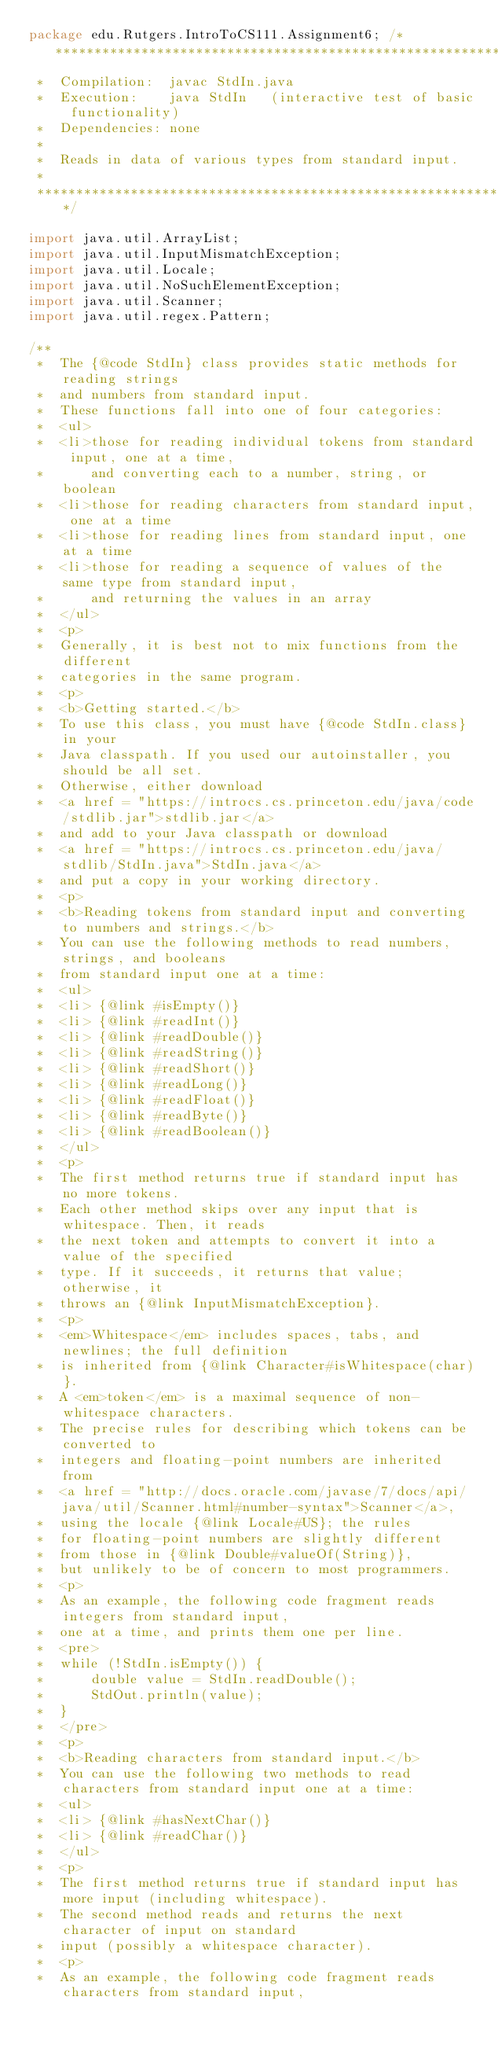Convert code to text. <code><loc_0><loc_0><loc_500><loc_500><_Java_>package edu.Rutgers.IntroToCS111.Assignment6; /******************************************************************************
 *  Compilation:  javac StdIn.java
 *  Execution:    java StdIn   (interactive test of basic functionality)
 *  Dependencies: none
 *
 *  Reads in data of various types from standard input.
 *
 ******************************************************************************/

import java.util.ArrayList;
import java.util.InputMismatchException;
import java.util.Locale;
import java.util.NoSuchElementException;
import java.util.Scanner;
import java.util.regex.Pattern;

/**
 *  The {@code StdIn} class provides static methods for reading strings
 *  and numbers from standard input.
 *  These functions fall into one of four categories:
 *  <ul>
 *  <li>those for reading individual tokens from standard input, one at a time,
 *      and converting each to a number, string, or boolean
 *  <li>those for reading characters from standard input, one at a time
 *  <li>those for reading lines from standard input, one at a time
 *  <li>those for reading a sequence of values of the same type from standard input,
 *      and returning the values in an array
 *  </ul>
 *  <p>
 *  Generally, it is best not to mix functions from the different
 *  categories in the same program.
 *  <p>
 *  <b>Getting started.</b>
 *  To use this class, you must have {@code StdIn.class} in your
 *  Java classpath. If you used our autoinstaller, you should be all set.
 *  Otherwise, either download
 *  <a href = "https://introcs.cs.princeton.edu/java/code/stdlib.jar">stdlib.jar</a>
 *  and add to your Java classpath or download
 *  <a href = "https://introcs.cs.princeton.edu/java/stdlib/StdIn.java">StdIn.java</a>
 *  and put a copy in your working directory.
 *  <p>
 *  <b>Reading tokens from standard input and converting to numbers and strings.</b>
 *  You can use the following methods to read numbers, strings, and booleans
 *  from standard input one at a time:
 *  <ul>
 *  <li> {@link #isEmpty()}
 *  <li> {@link #readInt()}
 *  <li> {@link #readDouble()}
 *  <li> {@link #readString()}
 *  <li> {@link #readShort()}
 *  <li> {@link #readLong()}
 *  <li> {@link #readFloat()}
 *  <li> {@link #readByte()}
 *  <li> {@link #readBoolean()}
 *  </ul>
 *  <p>
 *  The first method returns true if standard input has no more tokens.
 *  Each other method skips over any input that is whitespace. Then, it reads
 *  the next token and attempts to convert it into a value of the specified
 *  type. If it succeeds, it returns that value; otherwise, it
 *  throws an {@link InputMismatchException}.
 *  <p>
 *  <em>Whitespace</em> includes spaces, tabs, and newlines; the full definition
 *  is inherited from {@link Character#isWhitespace(char)}.
 *  A <em>token</em> is a maximal sequence of non-whitespace characters.
 *  The precise rules for describing which tokens can be converted to
 *  integers and floating-point numbers are inherited from
 *  <a href = "http://docs.oracle.com/javase/7/docs/api/java/util/Scanner.html#number-syntax">Scanner</a>,
 *  using the locale {@link Locale#US}; the rules
 *  for floating-point numbers are slightly different
 *  from those in {@link Double#valueOf(String)},
 *  but unlikely to be of concern to most programmers.
 *  <p>
 *  As an example, the following code fragment reads integers from standard input,
 *  one at a time, and prints them one per line.
 *  <pre>
 *  while (!StdIn.isEmpty()) {
 *      double value = StdIn.readDouble();
 *      StdOut.println(value);
 *  }
 *  </pre>
 *  <p>
 *  <b>Reading characters from standard input.</b>
 *  You can use the following two methods to read characters from standard input one at a time:
 *  <ul>
 *  <li> {@link #hasNextChar()}
 *  <li> {@link #readChar()}
 *  </ul>
 *  <p>
 *  The first method returns true if standard input has more input (including whitespace).
 *  The second method reads and returns the next character of input on standard 
 *  input (possibly a whitespace character).
 *  <p>
 *  As an example, the following code fragment reads characters from standard input,</code> 